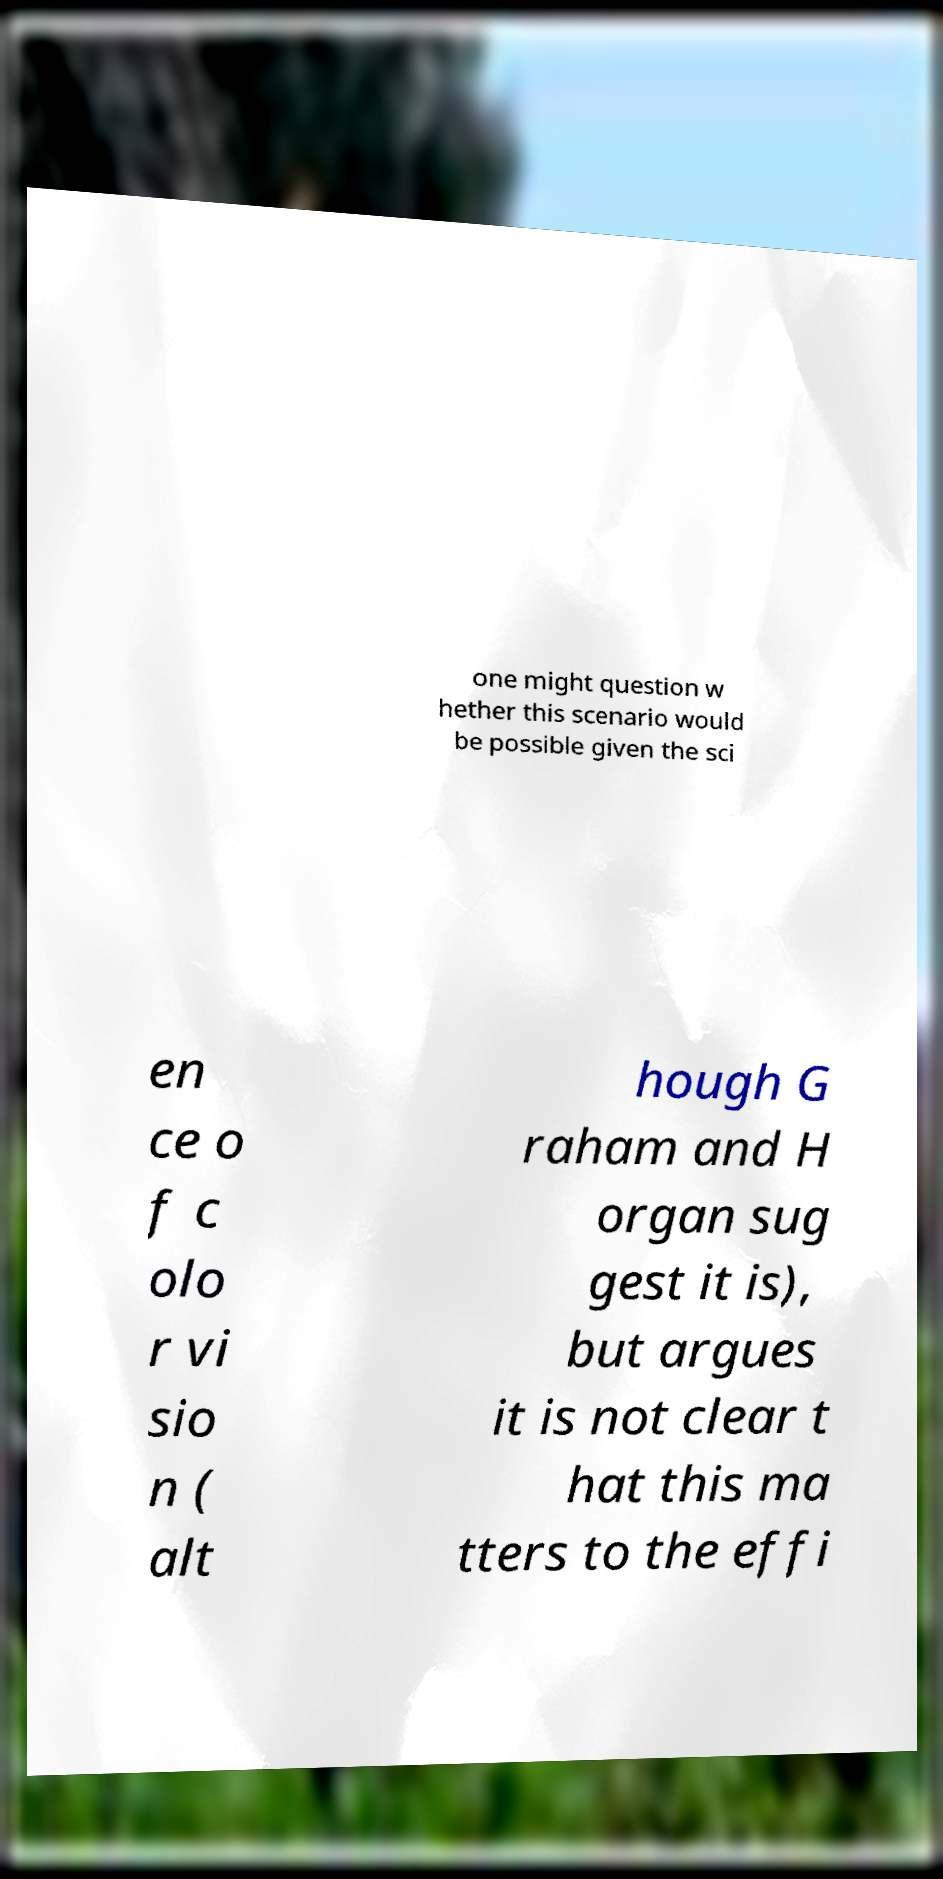I need the written content from this picture converted into text. Can you do that? one might question w hether this scenario would be possible given the sci en ce o f c olo r vi sio n ( alt hough G raham and H organ sug gest it is), but argues it is not clear t hat this ma tters to the effi 